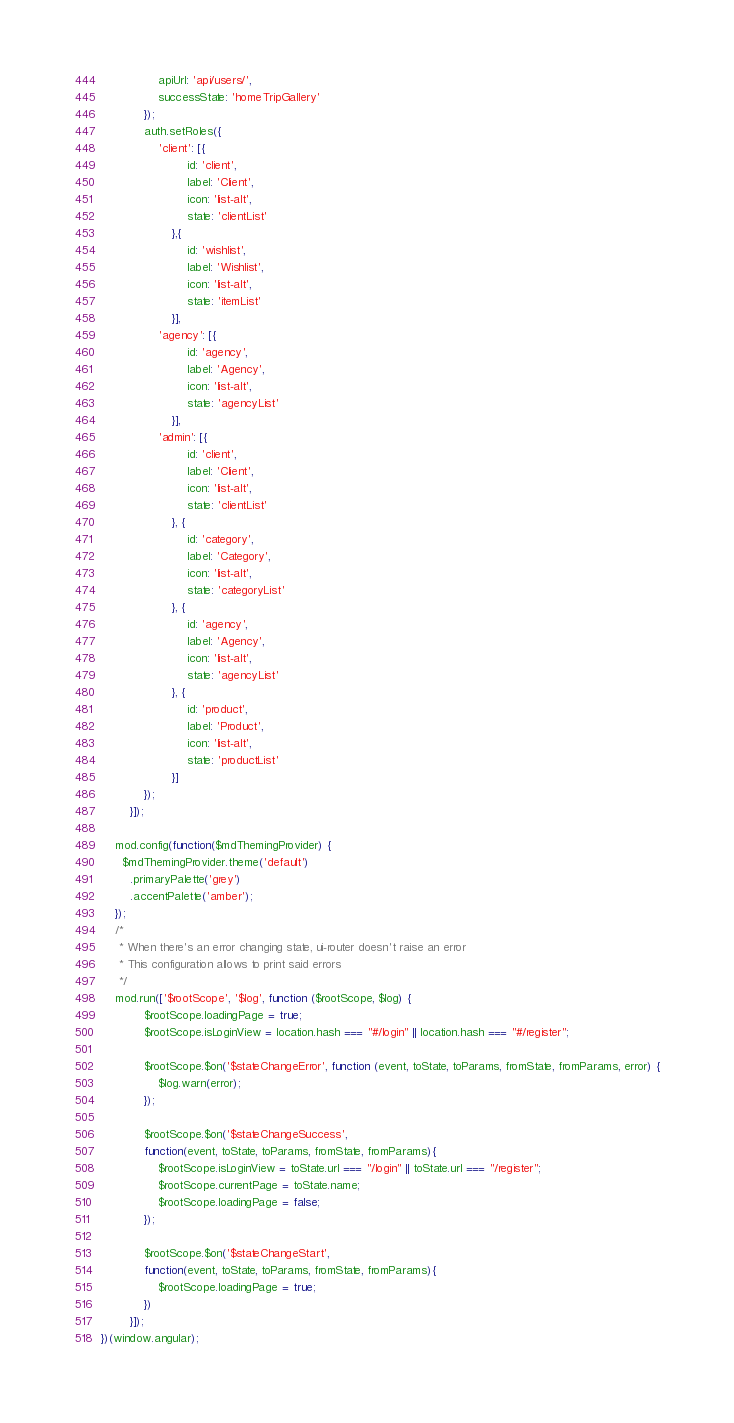<code> <loc_0><loc_0><loc_500><loc_500><_JavaScript_>                apiUrl: 'api/users/',
                successState: 'homeTripGallery'
            });
            auth.setRoles({
                'client': [{
                        id: 'client',
                        label: 'Client',
                        icon: 'list-alt',
                        state: 'clientList'
                    },{
                        id: 'wishlist',
                        label: 'Wishlist',
                        icon: 'list-alt',
                        state: 'itemList'
                    }],
                'agency': [{
                        id: 'agency',
                        label: 'Agency',
                        icon: 'list-alt',
                        state: 'agencyList'
                    }],
                'admin': [{
                        id: 'client',
                        label: 'Client',
                        icon: 'list-alt',
                        state: 'clientList'
                    }, {
                        id: 'category',
                        label: 'Category',
                        icon: 'list-alt',
                        state: 'categoryList'
                    }, {
                        id: 'agency',
                        label: 'Agency',
                        icon: 'list-alt',
                        state: 'agencyList'
                    }, {
                        id: 'product',
                        label: 'Product',
                        icon: 'list-alt',
                        state: 'productList'
                    }]
            });
        }]);

    mod.config(function($mdThemingProvider) {
      $mdThemingProvider.theme('default')
        .primaryPalette('grey')
        .accentPalette('amber');
    });
    /*
     * When there's an error changing state, ui-router doesn't raise an error
     * This configuration allows to print said errors
     */
    mod.run(['$rootScope', '$log', function ($rootScope, $log) {
            $rootScope.loadingPage = true;
            $rootScope.isLoginView = location.hash === "#/login" || location.hash === "#/register";
            
            $rootScope.$on('$stateChangeError', function (event, toState, toParams, fromState, fromParams, error) {
                $log.warn(error);
            });
            
            $rootScope.$on('$stateChangeSuccess', 
            function(event, toState, toParams, fromState, fromParams){ 
                $rootScope.isLoginView = toState.url === "/login" || toState.url === "/register";
                $rootScope.currentPage = toState.name;
                $rootScope.loadingPage = false;
            });
            
            $rootScope.$on('$stateChangeStart', 
            function(event, toState, toParams, fromState, fromParams){ 
                $rootScope.loadingPage = true;
            })
        }]);
})(window.angular);
</code> 